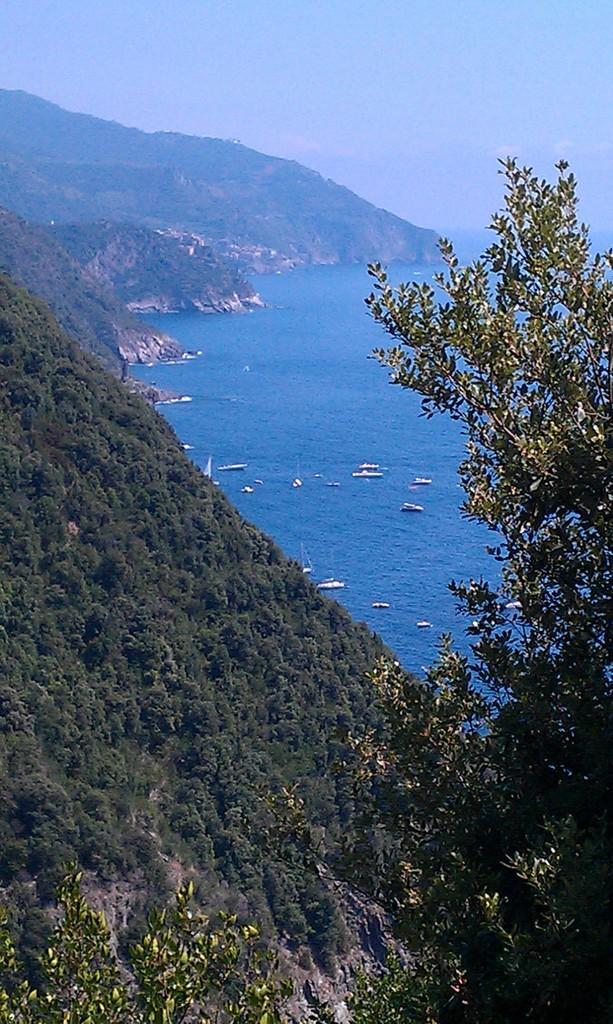Could you give a brief overview of what you see in this image? In this picture, we can see trees, some boats on the water, hills and a sky. 